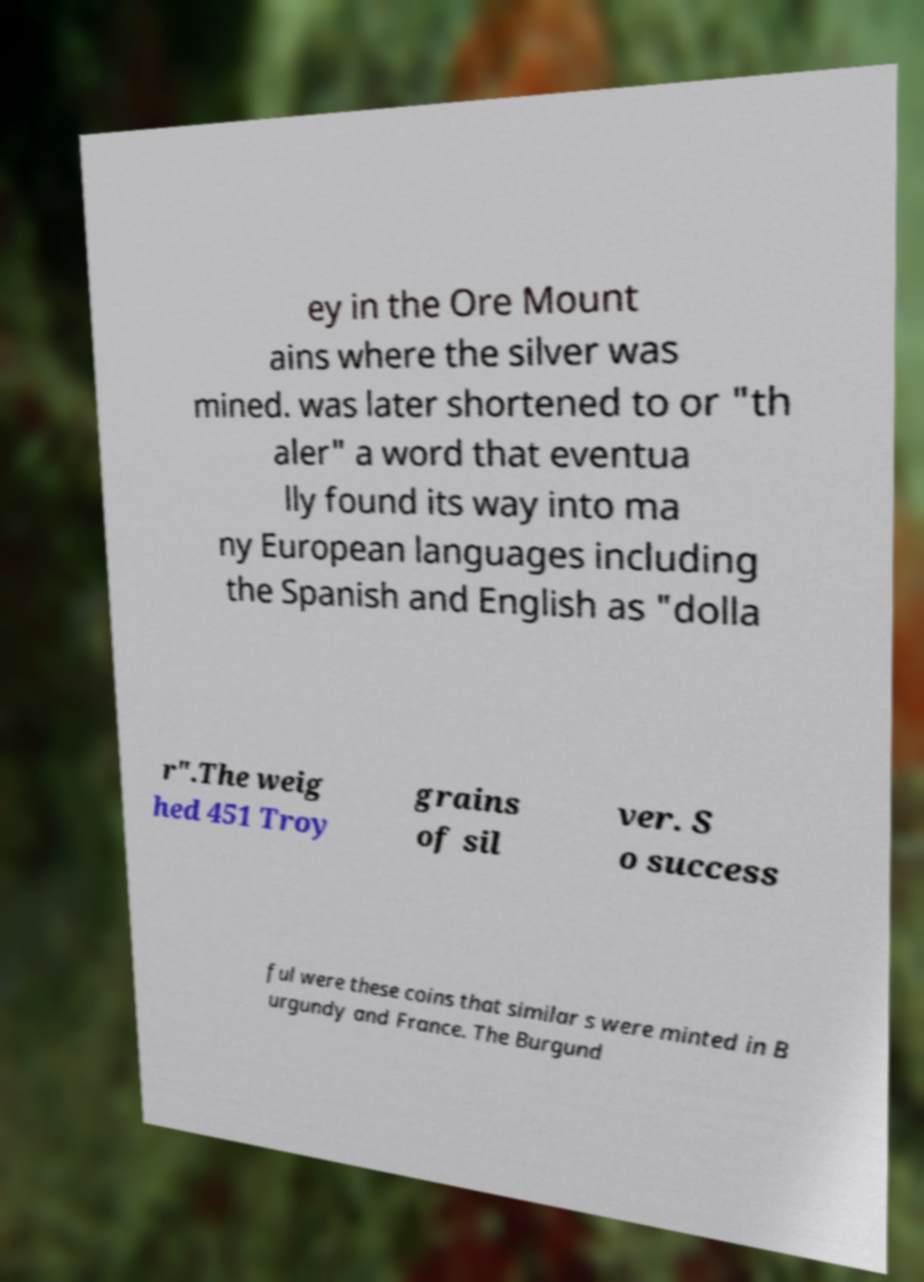Please identify and transcribe the text found in this image. ey in the Ore Mount ains where the silver was mined. was later shortened to or "th aler" a word that eventua lly found its way into ma ny European languages including the Spanish and English as "dolla r".The weig hed 451 Troy grains of sil ver. S o success ful were these coins that similar s were minted in B urgundy and France. The Burgund 